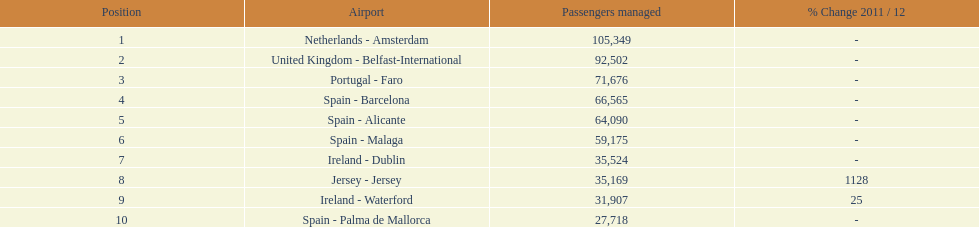How many passengers were handled in an airport in spain? 217,548. 